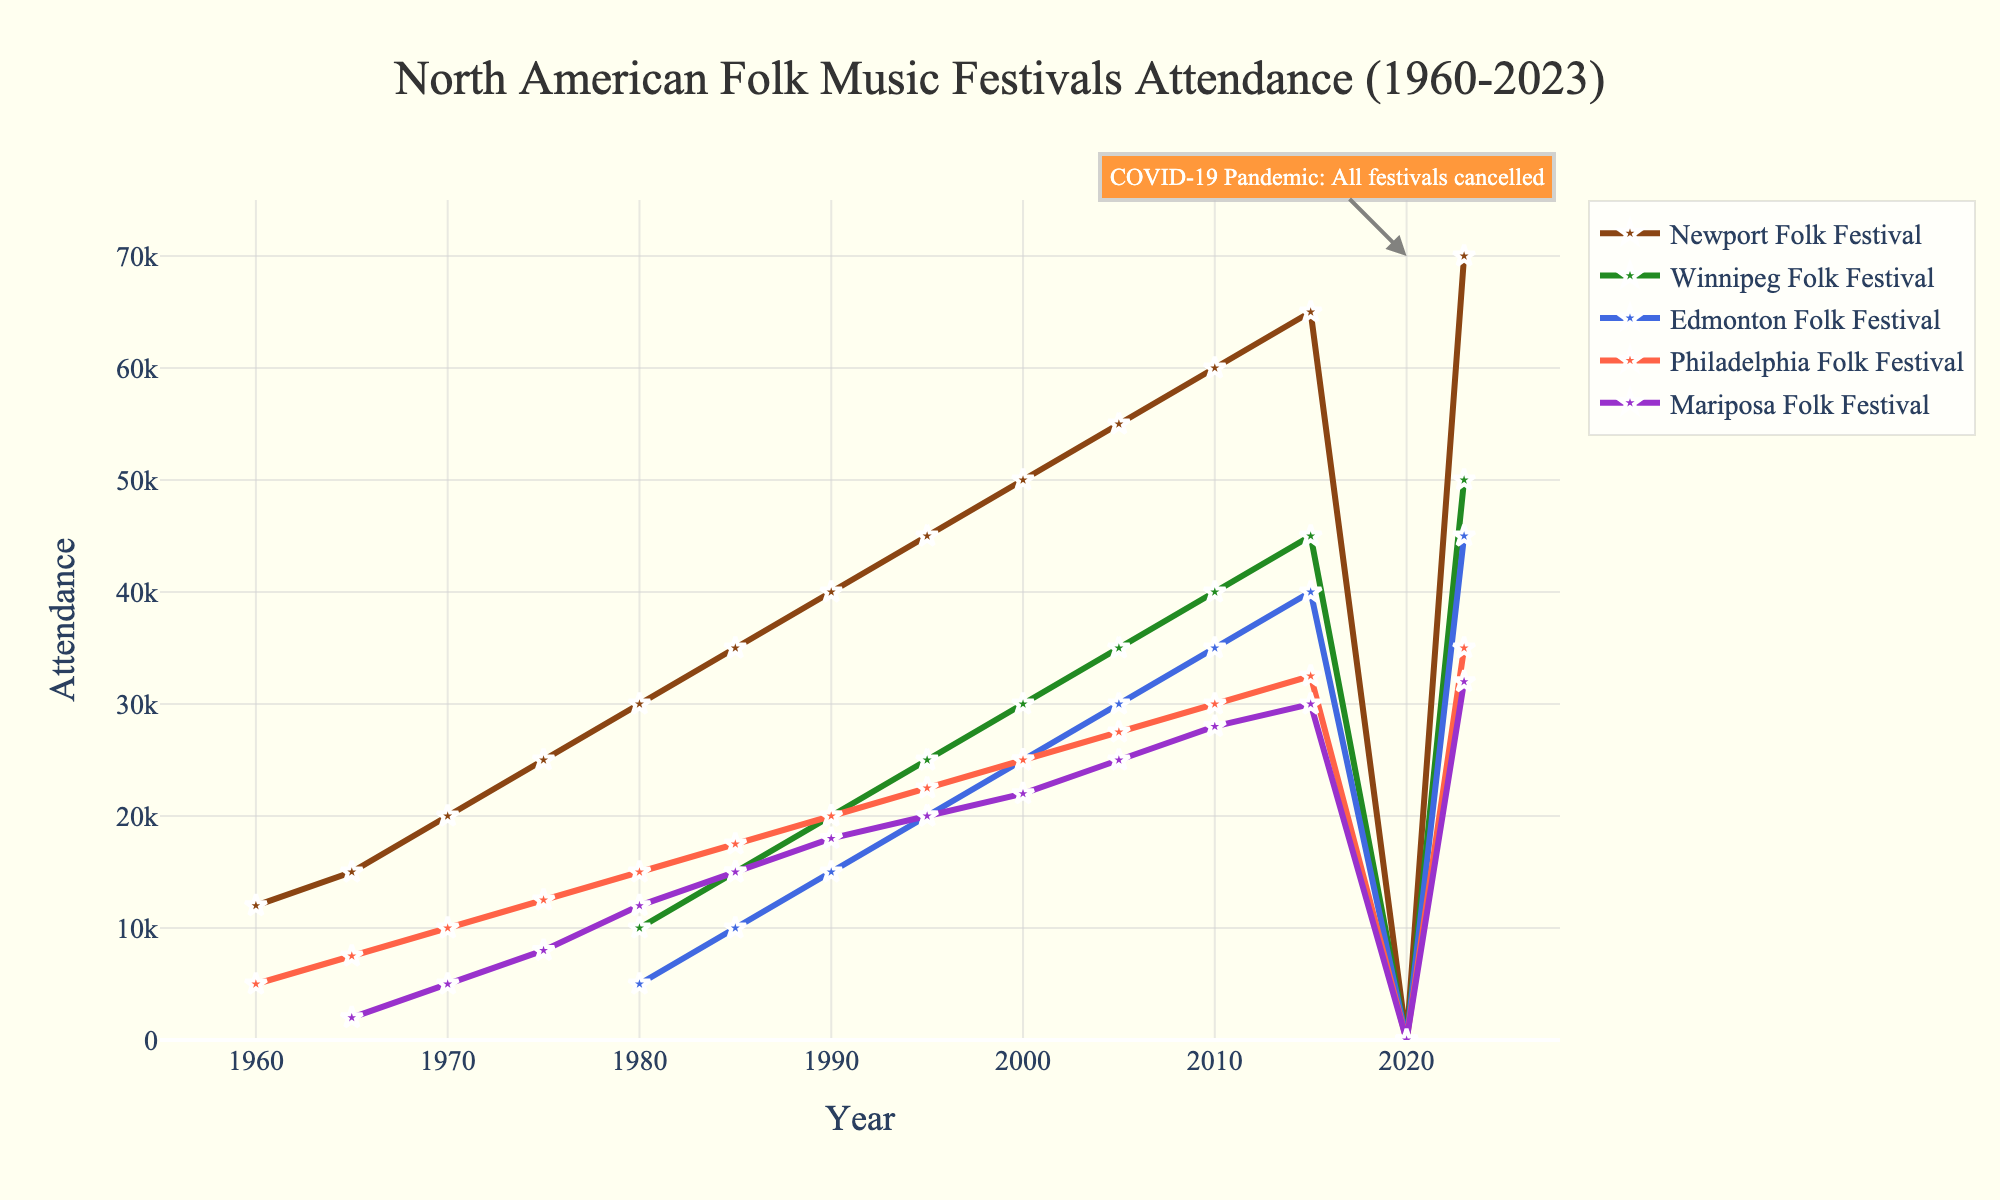What's the difference in attendance between the Newport Folk Festival and the Winnipeg Folk Festival in 1985? To find the difference in attendance between the Newport Folk Festival and the Winnipeg Folk Festival in 1985, we look at the attendance figures for each festival in that year. Newport Folk Festival had 35,000 attendees and Winnipeg Folk Festival had 15,000 attendees. The difference is 35,000 - 15,000 = 20,000.
Answer: 20,000 How did the attendance of the Mariposa Folk Festival change from 1965 to 1970? To see the change in attendance, we need to look at the attendance figures for the Mariposa Folk Festival in 1965 and 1970. In 1965, attendance was 2,000 and in 1970, it increased to 5,000. The change is 5,000 - 2,000 = 3,000.
Answer: Increased by 3,000 Which festival had the highest attendance in 2023? To determine which festival had the highest attendance in 2023, we need to compare the attendance figures for all the festivals in that year. Newport Folk Festival had 70,000, Winnipeg Folk Festival had 50,000, Edmonton Folk Festival had 45,000, Philadelphia Folk Festival had 35,000, and Mariposa Folk Festival had 32,000. The Newport Folk Festival had the highest attendance.
Answer: Newport Folk Festival How many festivals were cancelled in 2020 due to the COVID-19 pandemic? To find out how many festivals were cancelled, we look at the attendance figures for 2020. All festivals (Newport Folk Festival, Winnipeg Folk Festival, Edmonton Folk Festival, Philadelphia Folk Festival, and Mariposa Folk Festival) have an attendance of 0, indicating they were all cancelled.
Answer: 5 Compare the attendance trends of the Philadelphia Folk Festival and Edmonton Folk Festival from 1980 to 2023. To compare the trends, we examine the attendance data over the years from 1980 to 2023 for both festivals. Starting in 1980, Philadelphia Folk Festival attendance was 15,000 and grew steadily to 35,000 in 2023. The Edmonton Folk Festival started in 1980 with 5,000 attendees and grew to 45,000 in 2023. Both festivals show growth, but the Edmonton Folk Festival had a steeper increase overall.
Answer: Both increased; Edmonton Folk Festival had a steeper growth 